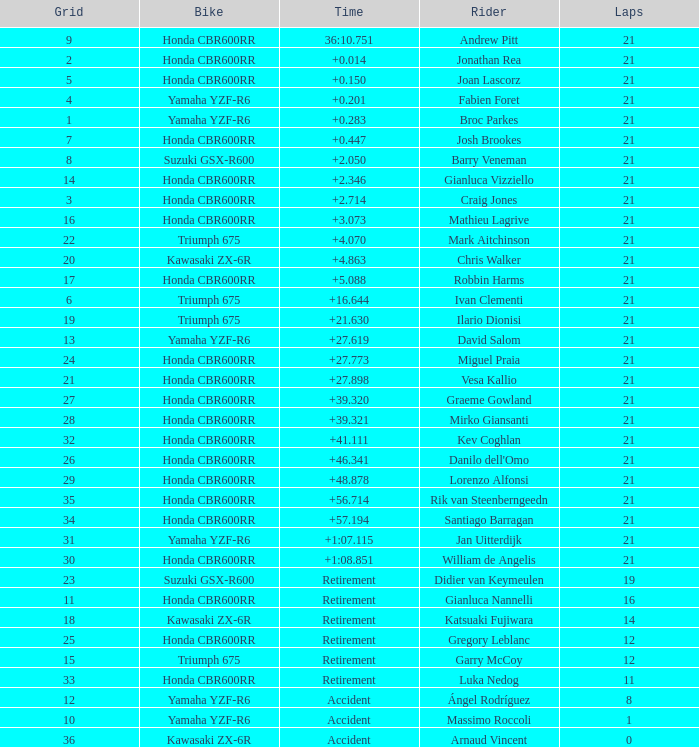What is the most number of laps run by Ilario Dionisi? 21.0. 